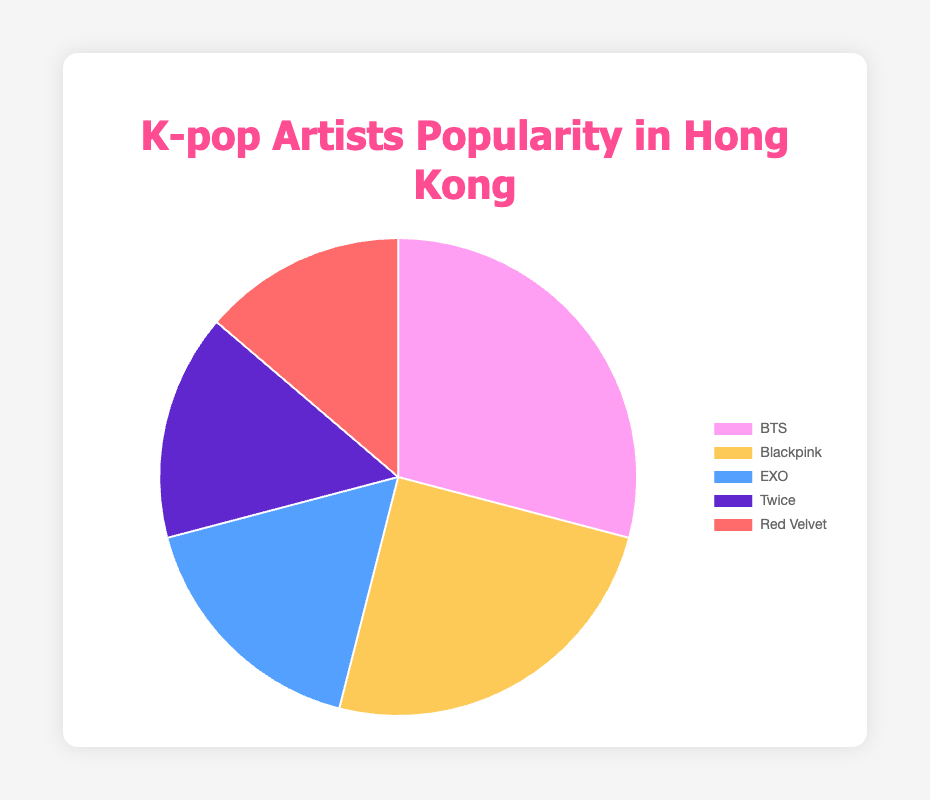What's the most popular K-pop artist in Hong Kong based on fan base size? The artist with the largest segment in the pie chart is the most popular. BTS has the largest segment.
Answer: BTS Which artist ranks second in popularity based on fan base size? By looking at the segments in descending order, the second largest segment represents Blackpink.
Answer: Blackpink What is the total fan base size of all the top 5 K-pop artists combined? Sum up the fan base sizes: 550,000 (BTS) + 470,000 (Blackpink) + 320,000 (EXO) + 290,000 (Twice) + 260,000 (Red Velvet). The total is 1,890,000.
Answer: 1,890,000 How many more fans does BTS have compared to EXO? Subtract the fan base of EXO from that of BTS: 550,000 - 320,000. BTS has 230,000 more fans.
Answer: 230,000 Which artist has the smallest fan base among the top 5? The artist with the smallest segment in the pie chart represents the smallest fan base. Red Velvet has the smallest segment.
Answer: Red Velvet What is the average fan base size of the five artists? Sum up the fan base sizes: 550,000 + 470,000 + 320,000 + 290,000 + 260,000 and divide by 5. The total is 1,890,000 and the average is 1,890,000 / 5 = 378,000.
Answer: 378,000 What is the combined fan base size of Blackpink and Twice? Sum up the fan base sizes of Blackpink and Twice: 470,000 + 290,000. The combined fan base is 760,000.
Answer: 760,000 Compare the fan base size of Twice to Red Velvet. Which is greater and by how much? Subtract the fan base of Red Velvet from that of Twice: 290,000 - 260,000. Twice has 30,000 more fans than Red Velvet.
Answer: Twice by 30,000 What percentage of the total fan base does BTS hold? Divide BTS's fan base size by the total fan base size and then multiply by 100 to get the percentage: (550,000 / 1,890,000) * 100. The percentage is approximately 29.1%.
Answer: 29.1% What are the colors representing BTS, EXO, and Red Velvet in the pie chart? By visually inspecting the pie chart, BTS is represented by pink, EXO by blue, and Red Velvet by red.
Answer: BTS: pink, EXO: blue, Red Velvet: red 